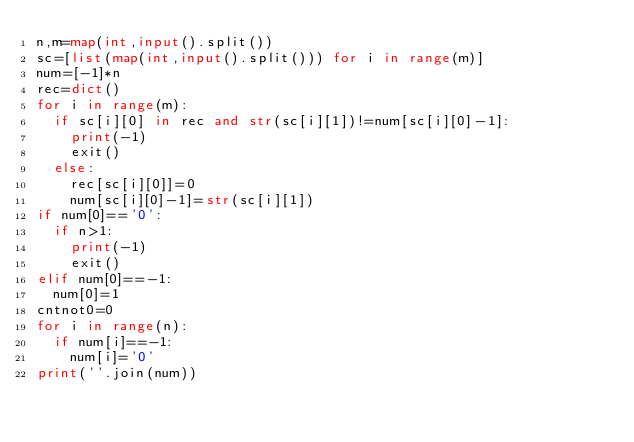<code> <loc_0><loc_0><loc_500><loc_500><_Python_>n,m=map(int,input().split())
sc=[list(map(int,input().split())) for i in range(m)]
num=[-1]*n
rec=dict()
for i in range(m):
  if sc[i][0] in rec and str(sc[i][1])!=num[sc[i][0]-1]:
    print(-1)
    exit()
  else:
    rec[sc[i][0]]=0
    num[sc[i][0]-1]=str(sc[i][1])
if num[0]=='0':
  if n>1:
    print(-1)
    exit()
elif num[0]==-1:
  num[0]=1
cntnot0=0
for i in range(n):
  if num[i]==-1:
    num[i]='0'
print(''.join(num))</code> 